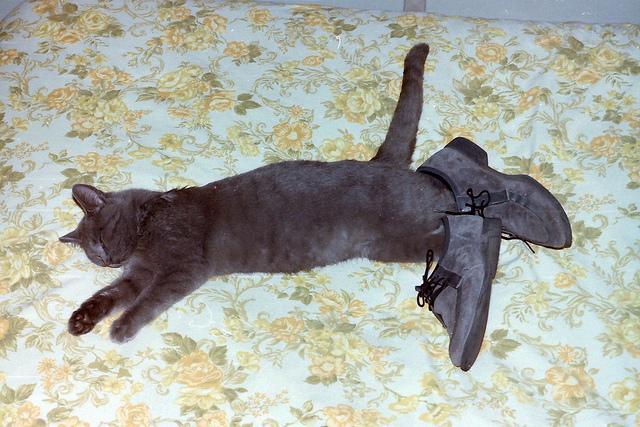How many cats can be seen?
Give a very brief answer. 1. How many people are here?
Give a very brief answer. 0. 